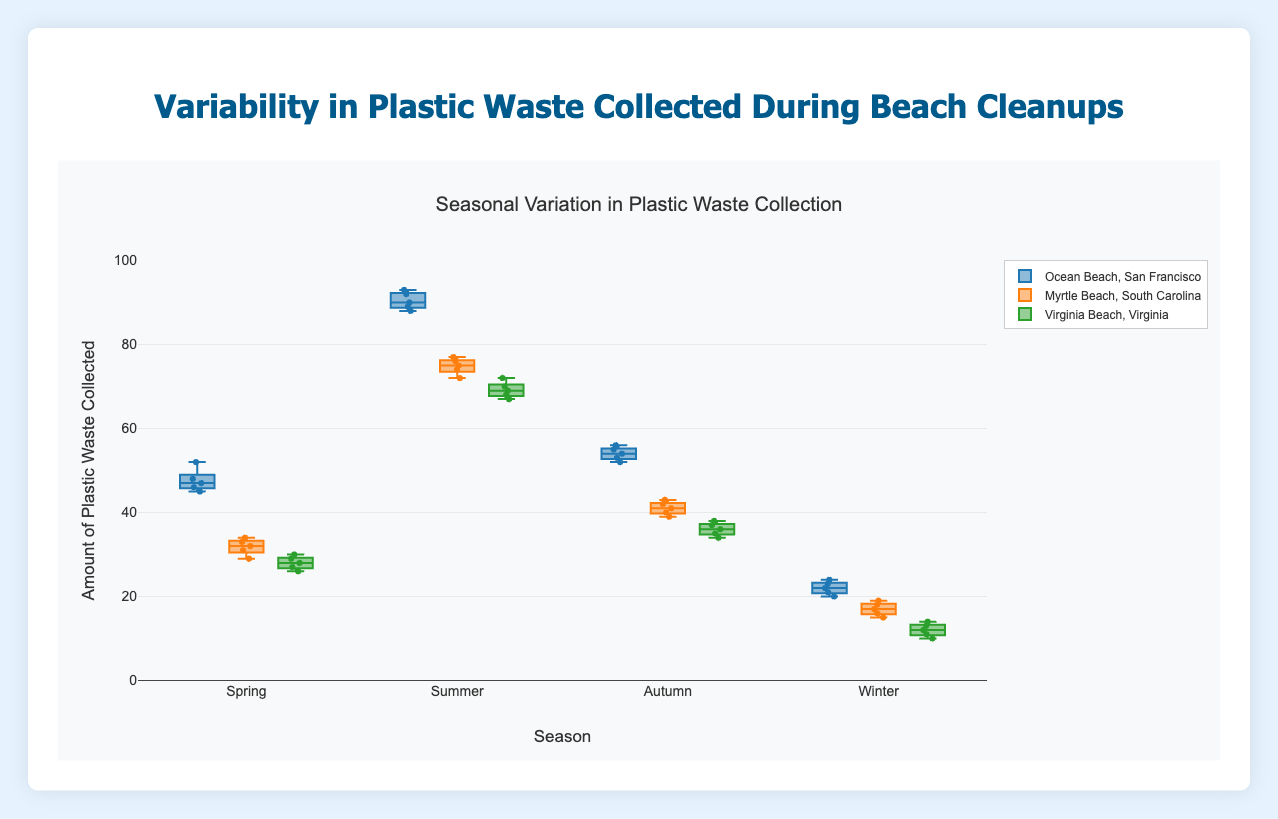How does the amount of plastic waste collected in Summer compare to Winter for Ocean Beach, San Francisco? Looking at the box plot for Ocean Beach, San Francisco, the boxplots for Summer show significantly higher values compared to Winter. For Summer, the values range around 88-93, whereas for Winter, the values are around 20-24.
Answer: Summer has significantly higher plastic waste collection than Winter What is the median amount of plastic waste collected in Autumn at Myrtle Beach, South Carolina? From the box plot for Autumn at Myrtle Beach, South Carolina, identify the line inside the box which represents the median. This line is around 41.
Answer: 41 Which beach collected the most plastic waste in Spring? By observing the highest point of boxplots in Spring, Ocean Beach, San Francisco has the highest values around 52.
Answer: Ocean Beach, San Francisco What is the interquartile range (IQR) of plastic waste collected in Summer at Virginia Beach, Virginia? IQR is the difference between the upper quartile (75th percentile) and lower quartile (25th percentile). For Summer at Virginia Beach, Virginia, the lower quartile is around 67 and the upper quartile is around 70. Therefore, the IQR is 70-67=3.
Answer: 3 What season has the least variability in plastic waste collected at Ocean Beach, San Francisco? Variability can be inferred from the height of the box in the box plot. For Ocean Beach, San Francisco, Winter shows the smallest box height, indicating the least variability.
Answer: Winter Which beach shows the highest variability in plastic waste collected during Summer? Variability is indicated by the height of the box in a box plot. In Summer, Ocean Beach, San Francisco has the largest box height, indicating the highest variability.
Answer: Ocean Beach, San Francisco How does the distribution of plastic waste collected in Autumn compare between Virginia Beach, Virginia and Myrtle Beach, South Carolina? By comparing the box plots for Autumn of both beaches, Myrtle Beach, South Carolina has a higher median and wider distribution (values around 39-43) compared to Virginia Beach, Virginia (values around 34-38).
Answer: Myrtle Beach, South Carolina has a higher median and wider distribution Which season shows the highest median collection of plastic waste at Virginia Beach, Virginia? By comparing the median lines inside the boxes for each season at Virginia Beach, Virginia, Summer has the highest median which is around 69.
Answer: Summer How does the amount of plastic waste collected in Spring at Ocean Beach, San Francisco compare to Myrtle Beach, South Carolina? Observing the box plots for Spring, the values for Ocean Beach, San Francisco (around 45-52) are higher compared to those for Myrtle Beach, South Carolina (around 29-34).
Answer: Ocean Beach, San Francisco has higher values compared to Myrtle Beach, South Carolina What is the range of plastic waste collected in Summer at Ocean Beach, San Francisco? The range is the difference between the maximum and minimum values. For Summer at Ocean Beach, San Francisco, the values range from 88 to 93, so the range is 93-88=5.
Answer: 5 